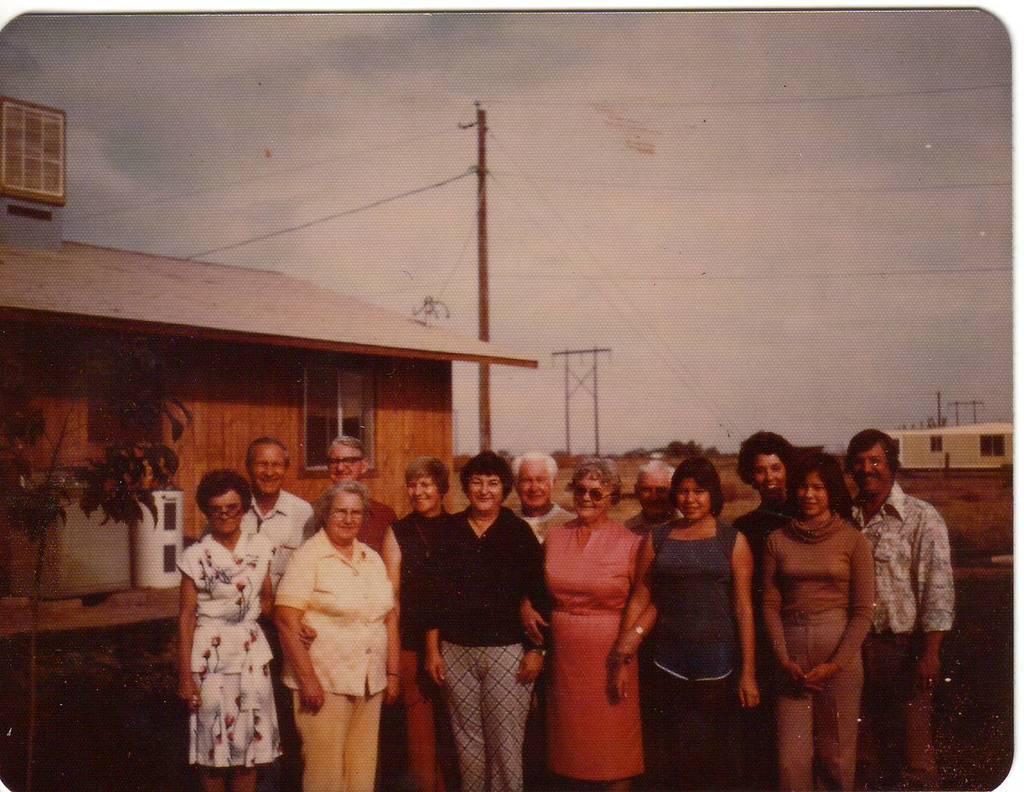In one or two sentences, can you explain what this image depicts? In this image I can see a group of people are standing together and smiling. On the left side there is a wooden house, in the middle there is a pole. At the top it is the sky. 